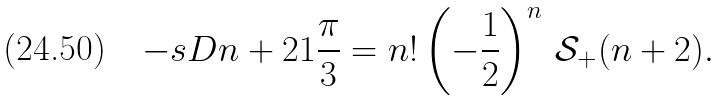<formula> <loc_0><loc_0><loc_500><loc_500>- \L s D { n + 2 } { 1 } { \frac { \pi } { 3 } } = n ! \left ( - \frac { 1 } 2 \right ) ^ { n } \, \mathcal { S } _ { + } ( n + 2 ) .</formula> 